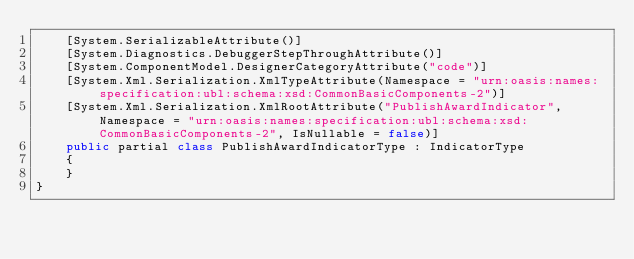<code> <loc_0><loc_0><loc_500><loc_500><_C#_>    [System.SerializableAttribute()]
    [System.Diagnostics.DebuggerStepThroughAttribute()]
    [System.ComponentModel.DesignerCategoryAttribute("code")]
    [System.Xml.Serialization.XmlTypeAttribute(Namespace = "urn:oasis:names:specification:ubl:schema:xsd:CommonBasicComponents-2")]
    [System.Xml.Serialization.XmlRootAttribute("PublishAwardIndicator", Namespace = "urn:oasis:names:specification:ubl:schema:xsd:CommonBasicComponents-2", IsNullable = false)]
    public partial class PublishAwardIndicatorType : IndicatorType
    {
    }
}</code> 